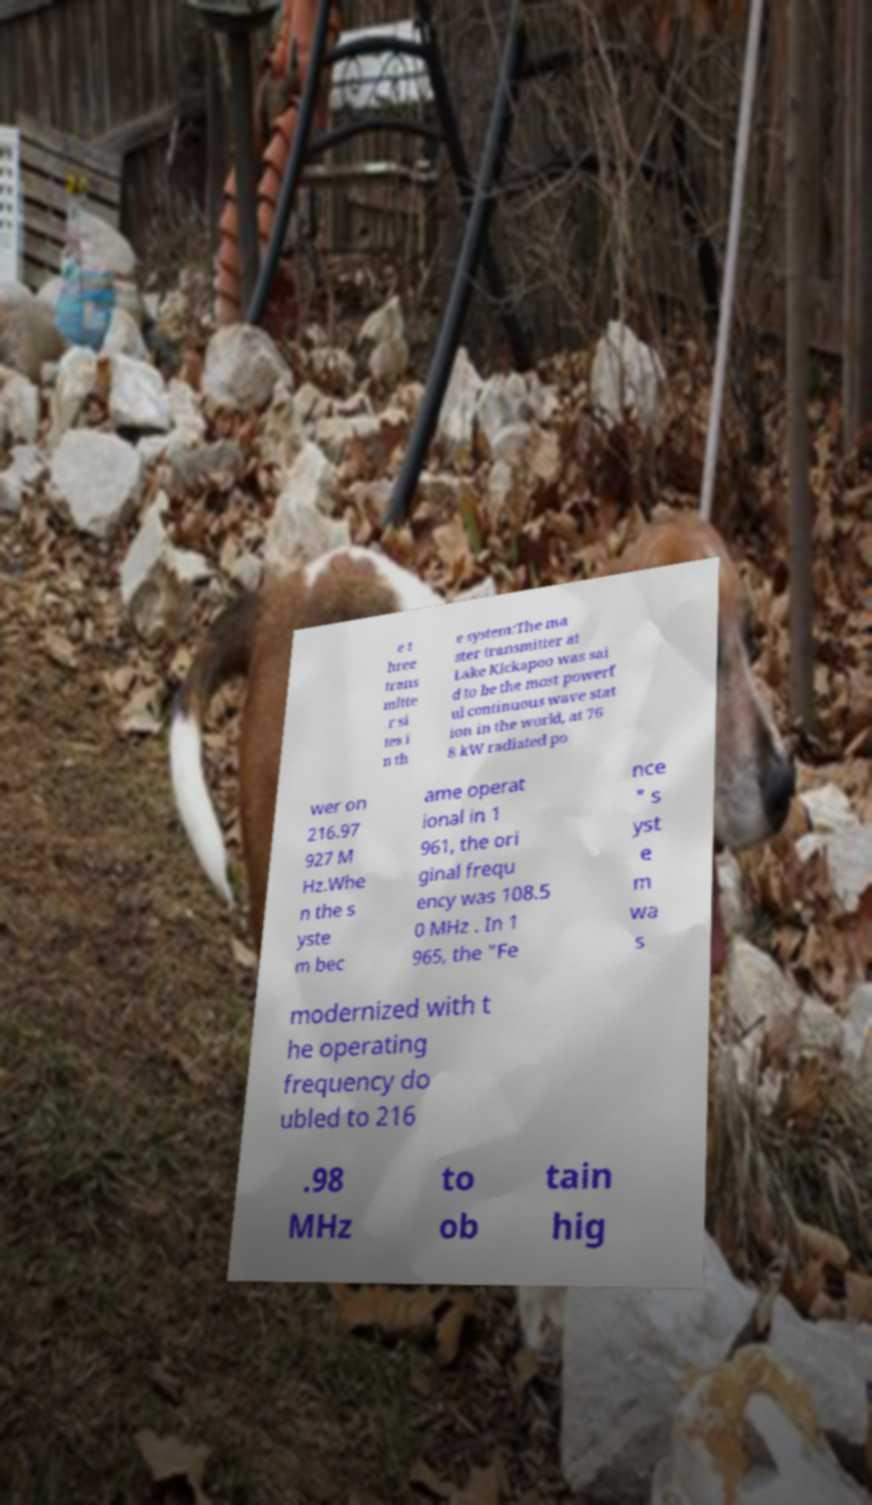Could you assist in decoding the text presented in this image and type it out clearly? e t hree trans mitte r si tes i n th e system:The ma ster transmitter at Lake Kickapoo was sai d to be the most powerf ul continuous wave stat ion in the world, at 76 8 kW radiated po wer on 216.97 927 M Hz.Whe n the s yste m bec ame operat ional in 1 961, the ori ginal frequ ency was 108.5 0 MHz . In 1 965, the "Fe nce " s yst e m wa s modernized with t he operating frequency do ubled to 216 .98 MHz to ob tain hig 